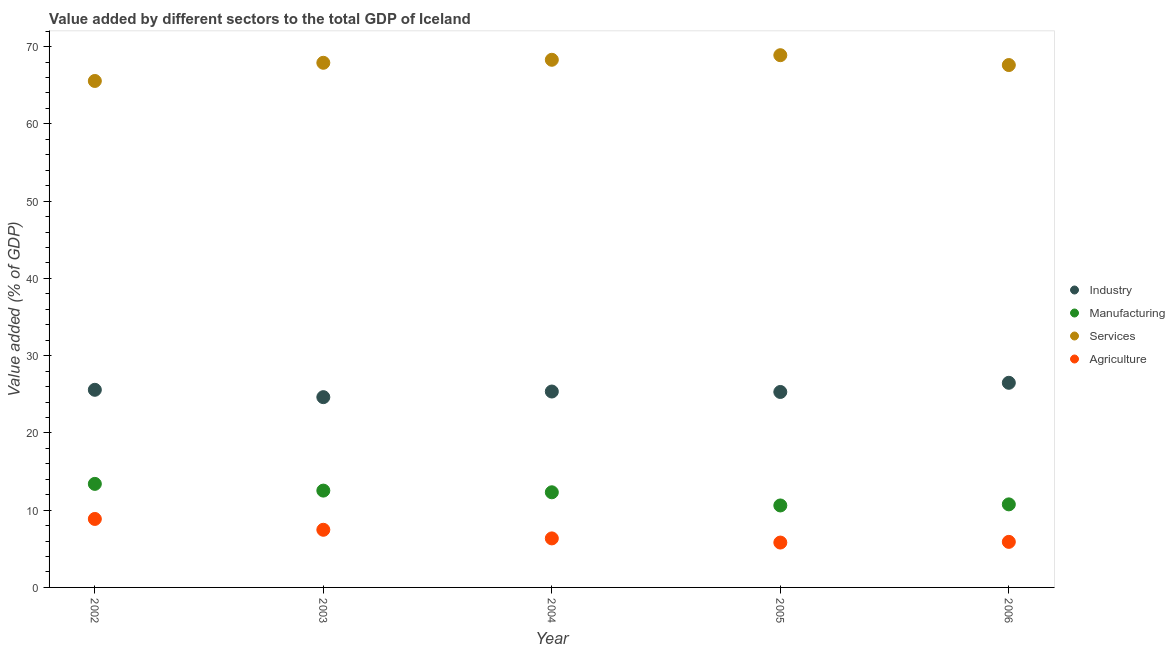What is the value added by manufacturing sector in 2002?
Ensure brevity in your answer.  13.4. Across all years, what is the maximum value added by industrial sector?
Give a very brief answer. 26.49. Across all years, what is the minimum value added by agricultural sector?
Ensure brevity in your answer.  5.81. In which year was the value added by industrial sector maximum?
Ensure brevity in your answer.  2006. In which year was the value added by industrial sector minimum?
Keep it short and to the point. 2003. What is the total value added by agricultural sector in the graph?
Provide a succinct answer. 34.38. What is the difference between the value added by manufacturing sector in 2005 and that in 2006?
Your answer should be very brief. -0.14. What is the difference between the value added by industrial sector in 2004 and the value added by services sector in 2005?
Give a very brief answer. -43.53. What is the average value added by agricultural sector per year?
Offer a terse response. 6.88. In the year 2003, what is the difference between the value added by agricultural sector and value added by services sector?
Ensure brevity in your answer.  -60.45. What is the ratio of the value added by industrial sector in 2002 to that in 2005?
Make the answer very short. 1.01. Is the difference between the value added by services sector in 2005 and 2006 greater than the difference between the value added by industrial sector in 2005 and 2006?
Ensure brevity in your answer.  Yes. What is the difference between the highest and the second highest value added by agricultural sector?
Provide a short and direct response. 1.4. What is the difference between the highest and the lowest value added by manufacturing sector?
Keep it short and to the point. 2.79. In how many years, is the value added by industrial sector greater than the average value added by industrial sector taken over all years?
Give a very brief answer. 2. Is the sum of the value added by agricultural sector in 2003 and 2005 greater than the maximum value added by services sector across all years?
Offer a very short reply. No. Is the value added by industrial sector strictly greater than the value added by manufacturing sector over the years?
Keep it short and to the point. Yes. Are the values on the major ticks of Y-axis written in scientific E-notation?
Your response must be concise. No. Does the graph contain any zero values?
Provide a short and direct response. No. Where does the legend appear in the graph?
Make the answer very short. Center right. How are the legend labels stacked?
Your answer should be compact. Vertical. What is the title of the graph?
Ensure brevity in your answer.  Value added by different sectors to the total GDP of Iceland. What is the label or title of the Y-axis?
Make the answer very short. Value added (% of GDP). What is the Value added (% of GDP) of Industry in 2002?
Provide a short and direct response. 25.58. What is the Value added (% of GDP) in Manufacturing in 2002?
Your answer should be very brief. 13.4. What is the Value added (% of GDP) in Services in 2002?
Your response must be concise. 65.56. What is the Value added (% of GDP) in Agriculture in 2002?
Provide a succinct answer. 8.86. What is the Value added (% of GDP) of Industry in 2003?
Provide a succinct answer. 24.63. What is the Value added (% of GDP) of Manufacturing in 2003?
Provide a short and direct response. 12.53. What is the Value added (% of GDP) in Services in 2003?
Provide a succinct answer. 67.91. What is the Value added (% of GDP) in Agriculture in 2003?
Make the answer very short. 7.46. What is the Value added (% of GDP) in Industry in 2004?
Offer a very short reply. 25.36. What is the Value added (% of GDP) in Manufacturing in 2004?
Keep it short and to the point. 12.31. What is the Value added (% of GDP) of Services in 2004?
Ensure brevity in your answer.  68.3. What is the Value added (% of GDP) of Agriculture in 2004?
Provide a short and direct response. 6.35. What is the Value added (% of GDP) in Industry in 2005?
Provide a succinct answer. 25.3. What is the Value added (% of GDP) in Manufacturing in 2005?
Provide a succinct answer. 10.61. What is the Value added (% of GDP) of Services in 2005?
Provide a succinct answer. 68.89. What is the Value added (% of GDP) of Agriculture in 2005?
Provide a succinct answer. 5.81. What is the Value added (% of GDP) of Industry in 2006?
Give a very brief answer. 26.49. What is the Value added (% of GDP) in Manufacturing in 2006?
Your answer should be very brief. 10.75. What is the Value added (% of GDP) in Services in 2006?
Your answer should be very brief. 67.62. What is the Value added (% of GDP) in Agriculture in 2006?
Your response must be concise. 5.9. Across all years, what is the maximum Value added (% of GDP) in Industry?
Offer a very short reply. 26.49. Across all years, what is the maximum Value added (% of GDP) of Manufacturing?
Provide a succinct answer. 13.4. Across all years, what is the maximum Value added (% of GDP) of Services?
Provide a succinct answer. 68.89. Across all years, what is the maximum Value added (% of GDP) of Agriculture?
Offer a terse response. 8.86. Across all years, what is the minimum Value added (% of GDP) of Industry?
Your answer should be very brief. 24.63. Across all years, what is the minimum Value added (% of GDP) of Manufacturing?
Make the answer very short. 10.61. Across all years, what is the minimum Value added (% of GDP) in Services?
Offer a terse response. 65.56. Across all years, what is the minimum Value added (% of GDP) in Agriculture?
Keep it short and to the point. 5.81. What is the total Value added (% of GDP) of Industry in the graph?
Your answer should be very brief. 127.35. What is the total Value added (% of GDP) of Manufacturing in the graph?
Provide a short and direct response. 59.61. What is the total Value added (% of GDP) of Services in the graph?
Ensure brevity in your answer.  338.27. What is the total Value added (% of GDP) of Agriculture in the graph?
Your answer should be very brief. 34.38. What is the difference between the Value added (% of GDP) of Industry in 2002 and that in 2003?
Offer a terse response. 0.95. What is the difference between the Value added (% of GDP) of Manufacturing in 2002 and that in 2003?
Your answer should be compact. 0.87. What is the difference between the Value added (% of GDP) of Services in 2002 and that in 2003?
Make the answer very short. -2.35. What is the difference between the Value added (% of GDP) of Agriculture in 2002 and that in 2003?
Your answer should be compact. 1.4. What is the difference between the Value added (% of GDP) of Industry in 2002 and that in 2004?
Your response must be concise. 0.22. What is the difference between the Value added (% of GDP) in Manufacturing in 2002 and that in 2004?
Give a very brief answer. 1.09. What is the difference between the Value added (% of GDP) of Services in 2002 and that in 2004?
Ensure brevity in your answer.  -2.74. What is the difference between the Value added (% of GDP) in Agriculture in 2002 and that in 2004?
Provide a short and direct response. 2.52. What is the difference between the Value added (% of GDP) of Industry in 2002 and that in 2005?
Your response must be concise. 0.28. What is the difference between the Value added (% of GDP) in Manufacturing in 2002 and that in 2005?
Keep it short and to the point. 2.79. What is the difference between the Value added (% of GDP) in Services in 2002 and that in 2005?
Ensure brevity in your answer.  -3.34. What is the difference between the Value added (% of GDP) of Agriculture in 2002 and that in 2005?
Keep it short and to the point. 3.06. What is the difference between the Value added (% of GDP) of Industry in 2002 and that in 2006?
Your answer should be compact. -0.91. What is the difference between the Value added (% of GDP) in Manufacturing in 2002 and that in 2006?
Make the answer very short. 2.65. What is the difference between the Value added (% of GDP) in Services in 2002 and that in 2006?
Your answer should be very brief. -2.06. What is the difference between the Value added (% of GDP) in Agriculture in 2002 and that in 2006?
Your response must be concise. 2.97. What is the difference between the Value added (% of GDP) in Industry in 2003 and that in 2004?
Your answer should be compact. -0.73. What is the difference between the Value added (% of GDP) in Manufacturing in 2003 and that in 2004?
Provide a succinct answer. 0.22. What is the difference between the Value added (% of GDP) of Services in 2003 and that in 2004?
Provide a short and direct response. -0.39. What is the difference between the Value added (% of GDP) in Agriculture in 2003 and that in 2004?
Make the answer very short. 1.12. What is the difference between the Value added (% of GDP) of Industry in 2003 and that in 2005?
Make the answer very short. -0.67. What is the difference between the Value added (% of GDP) in Manufacturing in 2003 and that in 2005?
Provide a short and direct response. 1.92. What is the difference between the Value added (% of GDP) of Services in 2003 and that in 2005?
Offer a very short reply. -0.98. What is the difference between the Value added (% of GDP) in Agriculture in 2003 and that in 2005?
Ensure brevity in your answer.  1.65. What is the difference between the Value added (% of GDP) in Industry in 2003 and that in 2006?
Make the answer very short. -1.86. What is the difference between the Value added (% of GDP) in Manufacturing in 2003 and that in 2006?
Ensure brevity in your answer.  1.78. What is the difference between the Value added (% of GDP) in Services in 2003 and that in 2006?
Ensure brevity in your answer.  0.29. What is the difference between the Value added (% of GDP) in Agriculture in 2003 and that in 2006?
Offer a terse response. 1.57. What is the difference between the Value added (% of GDP) of Industry in 2004 and that in 2005?
Provide a succinct answer. 0.06. What is the difference between the Value added (% of GDP) in Manufacturing in 2004 and that in 2005?
Your response must be concise. 1.71. What is the difference between the Value added (% of GDP) in Services in 2004 and that in 2005?
Ensure brevity in your answer.  -0.59. What is the difference between the Value added (% of GDP) in Agriculture in 2004 and that in 2005?
Your answer should be very brief. 0.54. What is the difference between the Value added (% of GDP) in Industry in 2004 and that in 2006?
Provide a short and direct response. -1.13. What is the difference between the Value added (% of GDP) in Manufacturing in 2004 and that in 2006?
Offer a terse response. 1.56. What is the difference between the Value added (% of GDP) of Services in 2004 and that in 2006?
Ensure brevity in your answer.  0.68. What is the difference between the Value added (% of GDP) of Agriculture in 2004 and that in 2006?
Your response must be concise. 0.45. What is the difference between the Value added (% of GDP) in Industry in 2005 and that in 2006?
Provide a short and direct response. -1.19. What is the difference between the Value added (% of GDP) of Manufacturing in 2005 and that in 2006?
Keep it short and to the point. -0.14. What is the difference between the Value added (% of GDP) in Services in 2005 and that in 2006?
Your answer should be compact. 1.28. What is the difference between the Value added (% of GDP) of Agriculture in 2005 and that in 2006?
Provide a succinct answer. -0.09. What is the difference between the Value added (% of GDP) of Industry in 2002 and the Value added (% of GDP) of Manufacturing in 2003?
Offer a very short reply. 13.05. What is the difference between the Value added (% of GDP) of Industry in 2002 and the Value added (% of GDP) of Services in 2003?
Ensure brevity in your answer.  -42.33. What is the difference between the Value added (% of GDP) of Industry in 2002 and the Value added (% of GDP) of Agriculture in 2003?
Ensure brevity in your answer.  18.12. What is the difference between the Value added (% of GDP) of Manufacturing in 2002 and the Value added (% of GDP) of Services in 2003?
Ensure brevity in your answer.  -54.51. What is the difference between the Value added (% of GDP) in Manufacturing in 2002 and the Value added (% of GDP) in Agriculture in 2003?
Make the answer very short. 5.94. What is the difference between the Value added (% of GDP) of Services in 2002 and the Value added (% of GDP) of Agriculture in 2003?
Your answer should be compact. 58.09. What is the difference between the Value added (% of GDP) in Industry in 2002 and the Value added (% of GDP) in Manufacturing in 2004?
Make the answer very short. 13.27. What is the difference between the Value added (% of GDP) in Industry in 2002 and the Value added (% of GDP) in Services in 2004?
Ensure brevity in your answer.  -42.72. What is the difference between the Value added (% of GDP) in Industry in 2002 and the Value added (% of GDP) in Agriculture in 2004?
Your response must be concise. 19.23. What is the difference between the Value added (% of GDP) of Manufacturing in 2002 and the Value added (% of GDP) of Services in 2004?
Your answer should be very brief. -54.9. What is the difference between the Value added (% of GDP) of Manufacturing in 2002 and the Value added (% of GDP) of Agriculture in 2004?
Provide a succinct answer. 7.06. What is the difference between the Value added (% of GDP) of Services in 2002 and the Value added (% of GDP) of Agriculture in 2004?
Give a very brief answer. 59.21. What is the difference between the Value added (% of GDP) of Industry in 2002 and the Value added (% of GDP) of Manufacturing in 2005?
Give a very brief answer. 14.97. What is the difference between the Value added (% of GDP) in Industry in 2002 and the Value added (% of GDP) in Services in 2005?
Ensure brevity in your answer.  -43.31. What is the difference between the Value added (% of GDP) in Industry in 2002 and the Value added (% of GDP) in Agriculture in 2005?
Ensure brevity in your answer.  19.77. What is the difference between the Value added (% of GDP) in Manufacturing in 2002 and the Value added (% of GDP) in Services in 2005?
Provide a short and direct response. -55.49. What is the difference between the Value added (% of GDP) of Manufacturing in 2002 and the Value added (% of GDP) of Agriculture in 2005?
Provide a short and direct response. 7.59. What is the difference between the Value added (% of GDP) in Services in 2002 and the Value added (% of GDP) in Agriculture in 2005?
Provide a succinct answer. 59.75. What is the difference between the Value added (% of GDP) in Industry in 2002 and the Value added (% of GDP) in Manufacturing in 2006?
Provide a succinct answer. 14.83. What is the difference between the Value added (% of GDP) of Industry in 2002 and the Value added (% of GDP) of Services in 2006?
Your answer should be very brief. -42.04. What is the difference between the Value added (% of GDP) of Industry in 2002 and the Value added (% of GDP) of Agriculture in 2006?
Provide a succinct answer. 19.68. What is the difference between the Value added (% of GDP) in Manufacturing in 2002 and the Value added (% of GDP) in Services in 2006?
Your answer should be compact. -54.21. What is the difference between the Value added (% of GDP) of Manufacturing in 2002 and the Value added (% of GDP) of Agriculture in 2006?
Offer a terse response. 7.51. What is the difference between the Value added (% of GDP) of Services in 2002 and the Value added (% of GDP) of Agriculture in 2006?
Offer a very short reply. 59.66. What is the difference between the Value added (% of GDP) in Industry in 2003 and the Value added (% of GDP) in Manufacturing in 2004?
Offer a terse response. 12.31. What is the difference between the Value added (% of GDP) of Industry in 2003 and the Value added (% of GDP) of Services in 2004?
Provide a short and direct response. -43.67. What is the difference between the Value added (% of GDP) in Industry in 2003 and the Value added (% of GDP) in Agriculture in 2004?
Your answer should be very brief. 18.28. What is the difference between the Value added (% of GDP) of Manufacturing in 2003 and the Value added (% of GDP) of Services in 2004?
Offer a terse response. -55.77. What is the difference between the Value added (% of GDP) of Manufacturing in 2003 and the Value added (% of GDP) of Agriculture in 2004?
Provide a short and direct response. 6.19. What is the difference between the Value added (% of GDP) in Services in 2003 and the Value added (% of GDP) in Agriculture in 2004?
Your answer should be compact. 61.56. What is the difference between the Value added (% of GDP) in Industry in 2003 and the Value added (% of GDP) in Manufacturing in 2005?
Provide a short and direct response. 14.02. What is the difference between the Value added (% of GDP) in Industry in 2003 and the Value added (% of GDP) in Services in 2005?
Offer a terse response. -44.26. What is the difference between the Value added (% of GDP) of Industry in 2003 and the Value added (% of GDP) of Agriculture in 2005?
Offer a very short reply. 18.82. What is the difference between the Value added (% of GDP) in Manufacturing in 2003 and the Value added (% of GDP) in Services in 2005?
Give a very brief answer. -56.36. What is the difference between the Value added (% of GDP) of Manufacturing in 2003 and the Value added (% of GDP) of Agriculture in 2005?
Keep it short and to the point. 6.72. What is the difference between the Value added (% of GDP) of Services in 2003 and the Value added (% of GDP) of Agriculture in 2005?
Your response must be concise. 62.1. What is the difference between the Value added (% of GDP) in Industry in 2003 and the Value added (% of GDP) in Manufacturing in 2006?
Offer a very short reply. 13.88. What is the difference between the Value added (% of GDP) in Industry in 2003 and the Value added (% of GDP) in Services in 2006?
Offer a terse response. -42.99. What is the difference between the Value added (% of GDP) in Industry in 2003 and the Value added (% of GDP) in Agriculture in 2006?
Your answer should be compact. 18.73. What is the difference between the Value added (% of GDP) of Manufacturing in 2003 and the Value added (% of GDP) of Services in 2006?
Ensure brevity in your answer.  -55.08. What is the difference between the Value added (% of GDP) in Manufacturing in 2003 and the Value added (% of GDP) in Agriculture in 2006?
Make the answer very short. 6.64. What is the difference between the Value added (% of GDP) of Services in 2003 and the Value added (% of GDP) of Agriculture in 2006?
Offer a terse response. 62.01. What is the difference between the Value added (% of GDP) of Industry in 2004 and the Value added (% of GDP) of Manufacturing in 2005?
Offer a terse response. 14.75. What is the difference between the Value added (% of GDP) of Industry in 2004 and the Value added (% of GDP) of Services in 2005?
Ensure brevity in your answer.  -43.53. What is the difference between the Value added (% of GDP) in Industry in 2004 and the Value added (% of GDP) in Agriculture in 2005?
Your answer should be very brief. 19.55. What is the difference between the Value added (% of GDP) in Manufacturing in 2004 and the Value added (% of GDP) in Services in 2005?
Your answer should be very brief. -56.58. What is the difference between the Value added (% of GDP) of Manufacturing in 2004 and the Value added (% of GDP) of Agriculture in 2005?
Give a very brief answer. 6.51. What is the difference between the Value added (% of GDP) in Services in 2004 and the Value added (% of GDP) in Agriculture in 2005?
Provide a succinct answer. 62.49. What is the difference between the Value added (% of GDP) of Industry in 2004 and the Value added (% of GDP) of Manufacturing in 2006?
Your response must be concise. 14.61. What is the difference between the Value added (% of GDP) in Industry in 2004 and the Value added (% of GDP) in Services in 2006?
Offer a very short reply. -42.26. What is the difference between the Value added (% of GDP) of Industry in 2004 and the Value added (% of GDP) of Agriculture in 2006?
Provide a short and direct response. 19.46. What is the difference between the Value added (% of GDP) in Manufacturing in 2004 and the Value added (% of GDP) in Services in 2006?
Your answer should be compact. -55.3. What is the difference between the Value added (% of GDP) in Manufacturing in 2004 and the Value added (% of GDP) in Agriculture in 2006?
Ensure brevity in your answer.  6.42. What is the difference between the Value added (% of GDP) in Services in 2004 and the Value added (% of GDP) in Agriculture in 2006?
Offer a terse response. 62.4. What is the difference between the Value added (% of GDP) in Industry in 2005 and the Value added (% of GDP) in Manufacturing in 2006?
Your answer should be compact. 14.55. What is the difference between the Value added (% of GDP) of Industry in 2005 and the Value added (% of GDP) of Services in 2006?
Provide a short and direct response. -42.32. What is the difference between the Value added (% of GDP) of Industry in 2005 and the Value added (% of GDP) of Agriculture in 2006?
Provide a short and direct response. 19.4. What is the difference between the Value added (% of GDP) of Manufacturing in 2005 and the Value added (% of GDP) of Services in 2006?
Make the answer very short. -57.01. What is the difference between the Value added (% of GDP) of Manufacturing in 2005 and the Value added (% of GDP) of Agriculture in 2006?
Offer a very short reply. 4.71. What is the difference between the Value added (% of GDP) of Services in 2005 and the Value added (% of GDP) of Agriculture in 2006?
Offer a very short reply. 63. What is the average Value added (% of GDP) in Industry per year?
Provide a short and direct response. 25.47. What is the average Value added (% of GDP) in Manufacturing per year?
Keep it short and to the point. 11.92. What is the average Value added (% of GDP) in Services per year?
Offer a terse response. 67.65. What is the average Value added (% of GDP) of Agriculture per year?
Your answer should be compact. 6.88. In the year 2002, what is the difference between the Value added (% of GDP) of Industry and Value added (% of GDP) of Manufacturing?
Make the answer very short. 12.18. In the year 2002, what is the difference between the Value added (% of GDP) of Industry and Value added (% of GDP) of Services?
Ensure brevity in your answer.  -39.98. In the year 2002, what is the difference between the Value added (% of GDP) of Industry and Value added (% of GDP) of Agriculture?
Offer a very short reply. 16.72. In the year 2002, what is the difference between the Value added (% of GDP) in Manufacturing and Value added (% of GDP) in Services?
Your response must be concise. -52.15. In the year 2002, what is the difference between the Value added (% of GDP) of Manufacturing and Value added (% of GDP) of Agriculture?
Your response must be concise. 4.54. In the year 2002, what is the difference between the Value added (% of GDP) of Services and Value added (% of GDP) of Agriculture?
Provide a short and direct response. 56.69. In the year 2003, what is the difference between the Value added (% of GDP) of Industry and Value added (% of GDP) of Manufacturing?
Give a very brief answer. 12.1. In the year 2003, what is the difference between the Value added (% of GDP) in Industry and Value added (% of GDP) in Services?
Keep it short and to the point. -43.28. In the year 2003, what is the difference between the Value added (% of GDP) of Industry and Value added (% of GDP) of Agriculture?
Ensure brevity in your answer.  17.17. In the year 2003, what is the difference between the Value added (% of GDP) in Manufacturing and Value added (% of GDP) in Services?
Provide a succinct answer. -55.38. In the year 2003, what is the difference between the Value added (% of GDP) of Manufacturing and Value added (% of GDP) of Agriculture?
Give a very brief answer. 5.07. In the year 2003, what is the difference between the Value added (% of GDP) of Services and Value added (% of GDP) of Agriculture?
Provide a succinct answer. 60.45. In the year 2004, what is the difference between the Value added (% of GDP) of Industry and Value added (% of GDP) of Manufacturing?
Provide a succinct answer. 13.04. In the year 2004, what is the difference between the Value added (% of GDP) of Industry and Value added (% of GDP) of Services?
Your response must be concise. -42.94. In the year 2004, what is the difference between the Value added (% of GDP) of Industry and Value added (% of GDP) of Agriculture?
Offer a terse response. 19.01. In the year 2004, what is the difference between the Value added (% of GDP) of Manufacturing and Value added (% of GDP) of Services?
Provide a succinct answer. -55.98. In the year 2004, what is the difference between the Value added (% of GDP) of Manufacturing and Value added (% of GDP) of Agriculture?
Offer a very short reply. 5.97. In the year 2004, what is the difference between the Value added (% of GDP) of Services and Value added (% of GDP) of Agriculture?
Ensure brevity in your answer.  61.95. In the year 2005, what is the difference between the Value added (% of GDP) of Industry and Value added (% of GDP) of Manufacturing?
Ensure brevity in your answer.  14.69. In the year 2005, what is the difference between the Value added (% of GDP) in Industry and Value added (% of GDP) in Services?
Offer a very short reply. -43.59. In the year 2005, what is the difference between the Value added (% of GDP) in Industry and Value added (% of GDP) in Agriculture?
Your answer should be compact. 19.49. In the year 2005, what is the difference between the Value added (% of GDP) in Manufacturing and Value added (% of GDP) in Services?
Offer a terse response. -58.28. In the year 2005, what is the difference between the Value added (% of GDP) of Manufacturing and Value added (% of GDP) of Agriculture?
Keep it short and to the point. 4.8. In the year 2005, what is the difference between the Value added (% of GDP) of Services and Value added (% of GDP) of Agriculture?
Offer a terse response. 63.08. In the year 2006, what is the difference between the Value added (% of GDP) in Industry and Value added (% of GDP) in Manufacturing?
Provide a succinct answer. 15.74. In the year 2006, what is the difference between the Value added (% of GDP) of Industry and Value added (% of GDP) of Services?
Provide a short and direct response. -41.13. In the year 2006, what is the difference between the Value added (% of GDP) in Industry and Value added (% of GDP) in Agriculture?
Provide a short and direct response. 20.59. In the year 2006, what is the difference between the Value added (% of GDP) of Manufacturing and Value added (% of GDP) of Services?
Provide a succinct answer. -56.87. In the year 2006, what is the difference between the Value added (% of GDP) of Manufacturing and Value added (% of GDP) of Agriculture?
Ensure brevity in your answer.  4.85. In the year 2006, what is the difference between the Value added (% of GDP) of Services and Value added (% of GDP) of Agriculture?
Your answer should be very brief. 61.72. What is the ratio of the Value added (% of GDP) of Industry in 2002 to that in 2003?
Your response must be concise. 1.04. What is the ratio of the Value added (% of GDP) of Manufacturing in 2002 to that in 2003?
Give a very brief answer. 1.07. What is the ratio of the Value added (% of GDP) of Services in 2002 to that in 2003?
Provide a short and direct response. 0.97. What is the ratio of the Value added (% of GDP) in Agriculture in 2002 to that in 2003?
Keep it short and to the point. 1.19. What is the ratio of the Value added (% of GDP) of Industry in 2002 to that in 2004?
Ensure brevity in your answer.  1.01. What is the ratio of the Value added (% of GDP) of Manufacturing in 2002 to that in 2004?
Make the answer very short. 1.09. What is the ratio of the Value added (% of GDP) of Services in 2002 to that in 2004?
Your answer should be compact. 0.96. What is the ratio of the Value added (% of GDP) in Agriculture in 2002 to that in 2004?
Offer a terse response. 1.4. What is the ratio of the Value added (% of GDP) of Industry in 2002 to that in 2005?
Provide a short and direct response. 1.01. What is the ratio of the Value added (% of GDP) in Manufacturing in 2002 to that in 2005?
Offer a terse response. 1.26. What is the ratio of the Value added (% of GDP) of Services in 2002 to that in 2005?
Offer a very short reply. 0.95. What is the ratio of the Value added (% of GDP) in Agriculture in 2002 to that in 2005?
Provide a succinct answer. 1.53. What is the ratio of the Value added (% of GDP) of Industry in 2002 to that in 2006?
Your response must be concise. 0.97. What is the ratio of the Value added (% of GDP) in Manufacturing in 2002 to that in 2006?
Your response must be concise. 1.25. What is the ratio of the Value added (% of GDP) of Services in 2002 to that in 2006?
Your answer should be compact. 0.97. What is the ratio of the Value added (% of GDP) of Agriculture in 2002 to that in 2006?
Provide a short and direct response. 1.5. What is the ratio of the Value added (% of GDP) in Industry in 2003 to that in 2004?
Your answer should be very brief. 0.97. What is the ratio of the Value added (% of GDP) of Manufacturing in 2003 to that in 2004?
Offer a very short reply. 1.02. What is the ratio of the Value added (% of GDP) of Agriculture in 2003 to that in 2004?
Ensure brevity in your answer.  1.18. What is the ratio of the Value added (% of GDP) of Industry in 2003 to that in 2005?
Provide a short and direct response. 0.97. What is the ratio of the Value added (% of GDP) in Manufacturing in 2003 to that in 2005?
Offer a terse response. 1.18. What is the ratio of the Value added (% of GDP) in Services in 2003 to that in 2005?
Your answer should be very brief. 0.99. What is the ratio of the Value added (% of GDP) of Agriculture in 2003 to that in 2005?
Your answer should be very brief. 1.28. What is the ratio of the Value added (% of GDP) of Industry in 2003 to that in 2006?
Give a very brief answer. 0.93. What is the ratio of the Value added (% of GDP) of Manufacturing in 2003 to that in 2006?
Your response must be concise. 1.17. What is the ratio of the Value added (% of GDP) of Services in 2003 to that in 2006?
Provide a short and direct response. 1. What is the ratio of the Value added (% of GDP) in Agriculture in 2003 to that in 2006?
Ensure brevity in your answer.  1.27. What is the ratio of the Value added (% of GDP) in Manufacturing in 2004 to that in 2005?
Provide a short and direct response. 1.16. What is the ratio of the Value added (% of GDP) in Agriculture in 2004 to that in 2005?
Give a very brief answer. 1.09. What is the ratio of the Value added (% of GDP) of Industry in 2004 to that in 2006?
Offer a very short reply. 0.96. What is the ratio of the Value added (% of GDP) of Manufacturing in 2004 to that in 2006?
Give a very brief answer. 1.15. What is the ratio of the Value added (% of GDP) in Agriculture in 2004 to that in 2006?
Your response must be concise. 1.08. What is the ratio of the Value added (% of GDP) in Industry in 2005 to that in 2006?
Ensure brevity in your answer.  0.96. What is the ratio of the Value added (% of GDP) in Manufacturing in 2005 to that in 2006?
Offer a very short reply. 0.99. What is the ratio of the Value added (% of GDP) of Services in 2005 to that in 2006?
Provide a short and direct response. 1.02. What is the difference between the highest and the second highest Value added (% of GDP) in Industry?
Ensure brevity in your answer.  0.91. What is the difference between the highest and the second highest Value added (% of GDP) of Manufacturing?
Give a very brief answer. 0.87. What is the difference between the highest and the second highest Value added (% of GDP) of Services?
Offer a terse response. 0.59. What is the difference between the highest and the second highest Value added (% of GDP) in Agriculture?
Provide a short and direct response. 1.4. What is the difference between the highest and the lowest Value added (% of GDP) of Industry?
Offer a very short reply. 1.86. What is the difference between the highest and the lowest Value added (% of GDP) of Manufacturing?
Ensure brevity in your answer.  2.79. What is the difference between the highest and the lowest Value added (% of GDP) of Services?
Make the answer very short. 3.34. What is the difference between the highest and the lowest Value added (% of GDP) of Agriculture?
Your answer should be very brief. 3.06. 